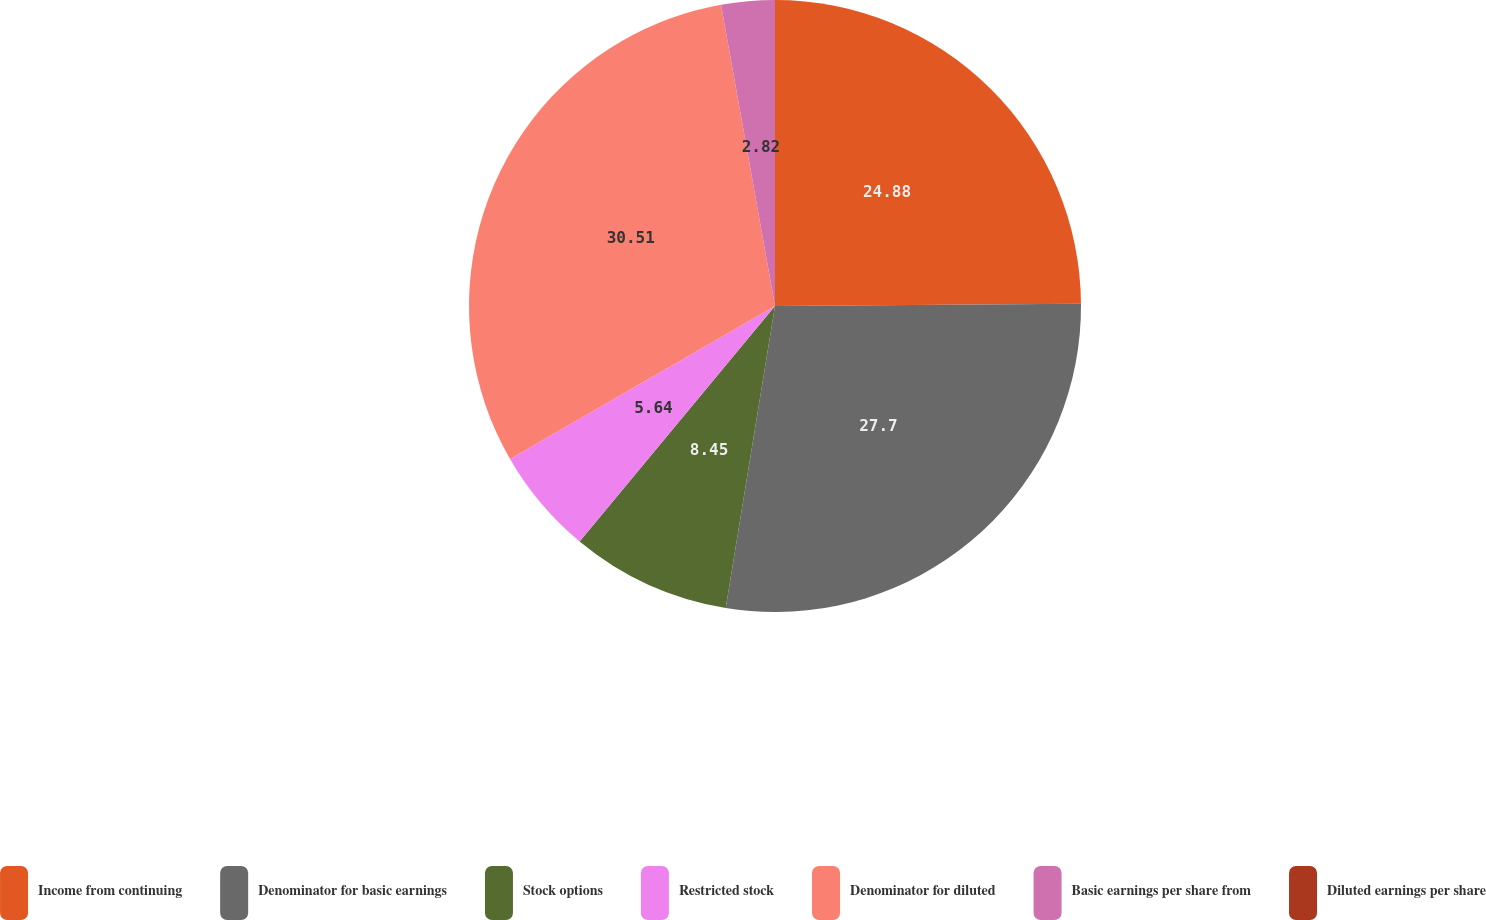Convert chart to OTSL. <chart><loc_0><loc_0><loc_500><loc_500><pie_chart><fcel>Income from continuing<fcel>Denominator for basic earnings<fcel>Stock options<fcel>Restricted stock<fcel>Denominator for diluted<fcel>Basic earnings per share from<fcel>Diluted earnings per share<nl><fcel>24.88%<fcel>27.7%<fcel>8.45%<fcel>5.64%<fcel>30.52%<fcel>2.82%<fcel>0.0%<nl></chart> 